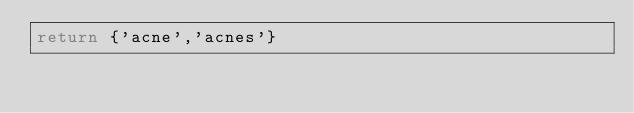Convert code to text. <code><loc_0><loc_0><loc_500><loc_500><_Lua_>return {'acne','acnes'}</code> 